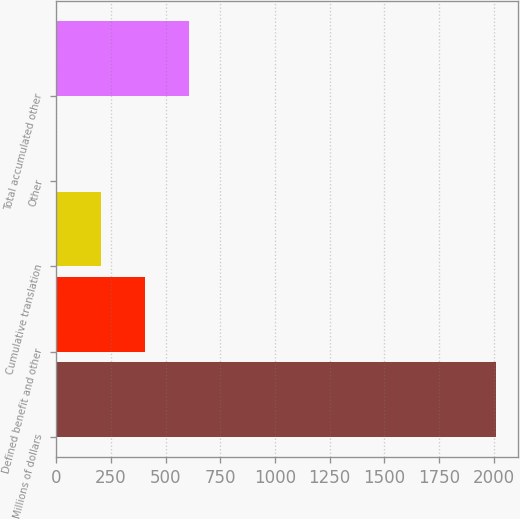Convert chart to OTSL. <chart><loc_0><loc_0><loc_500><loc_500><bar_chart><fcel>Millions of dollars<fcel>Defined benefit and other<fcel>Cumulative translation<fcel>Other<fcel>Total accumulated other<nl><fcel>2013<fcel>405<fcel>204<fcel>3<fcel>606<nl></chart> 